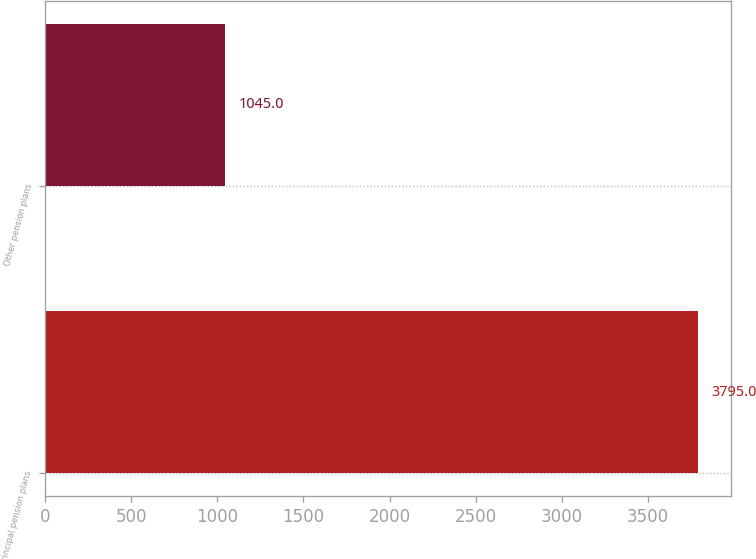Convert chart to OTSL. <chart><loc_0><loc_0><loc_500><loc_500><bar_chart><fcel>Principal pension plans<fcel>Other pension plans<nl><fcel>3795<fcel>1045<nl></chart> 